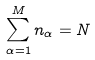Convert formula to latex. <formula><loc_0><loc_0><loc_500><loc_500>\sum _ { \alpha = 1 } ^ { M } n _ { \alpha } = N</formula> 